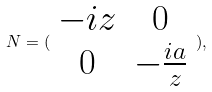<formula> <loc_0><loc_0><loc_500><loc_500>N = ( \begin{array} { c c } - i z & 0 \\ 0 & - \frac { i a } { z } \end{array} ) ,</formula> 